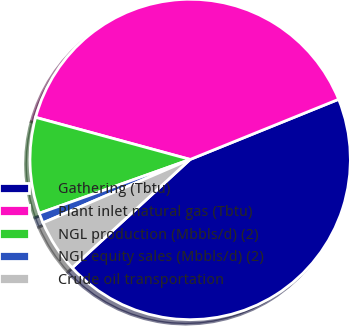Convert chart to OTSL. <chart><loc_0><loc_0><loc_500><loc_500><pie_chart><fcel>Gathering (Tbtu)<fcel>Plant inlet natural gas (Tbtu)<fcel>NGL production (Mbbls/d) (2)<fcel>NGL equity sales (Mbbls/d) (2)<fcel>Crude oil transportation<nl><fcel>44.3%<fcel>39.64%<fcel>9.68%<fcel>1.02%<fcel>5.35%<nl></chart> 